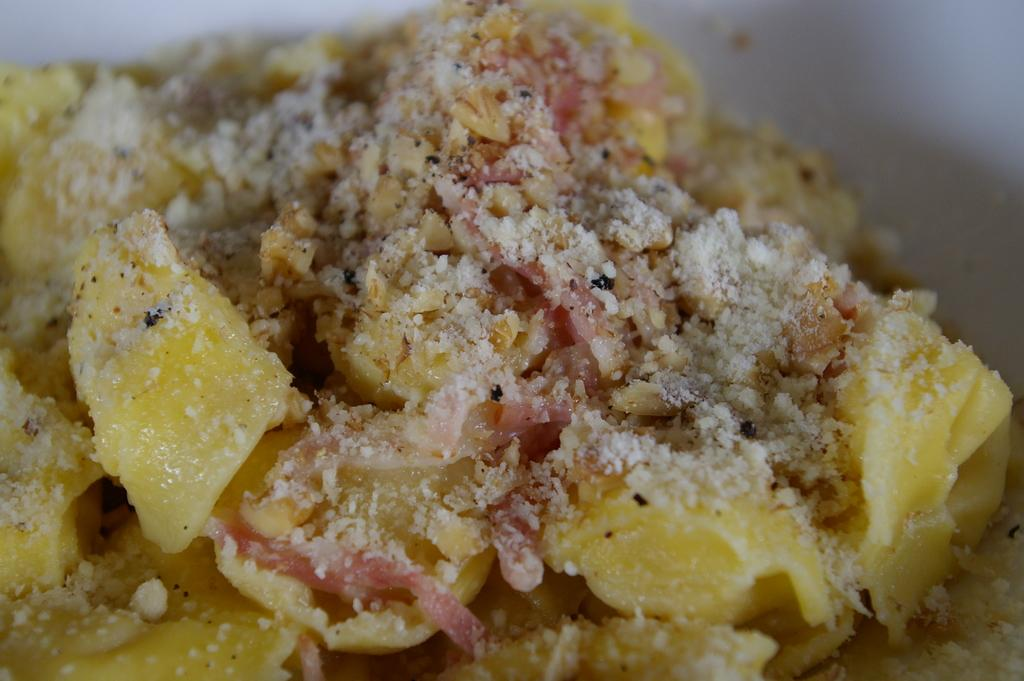What is the main subject of the image? There is a food item in the image. Can you describe the background of the image? There is a white color object in the background of the image. How many cacti are visible in the image? There are no cacti present in the image. What type of canvas is used to create the image? The facts provided do not mention the medium or canvas used to create the image. 